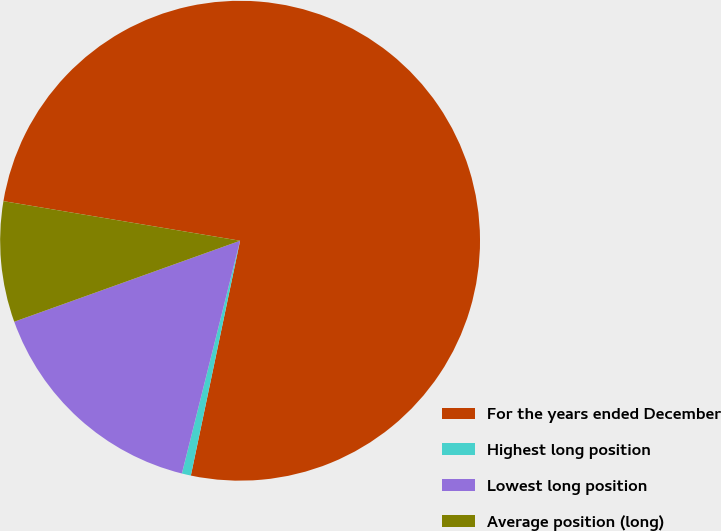Convert chart to OTSL. <chart><loc_0><loc_0><loc_500><loc_500><pie_chart><fcel>For the years ended December<fcel>Highest long position<fcel>Lowest long position<fcel>Average position (long)<nl><fcel>75.65%<fcel>0.61%<fcel>15.62%<fcel>8.12%<nl></chart> 